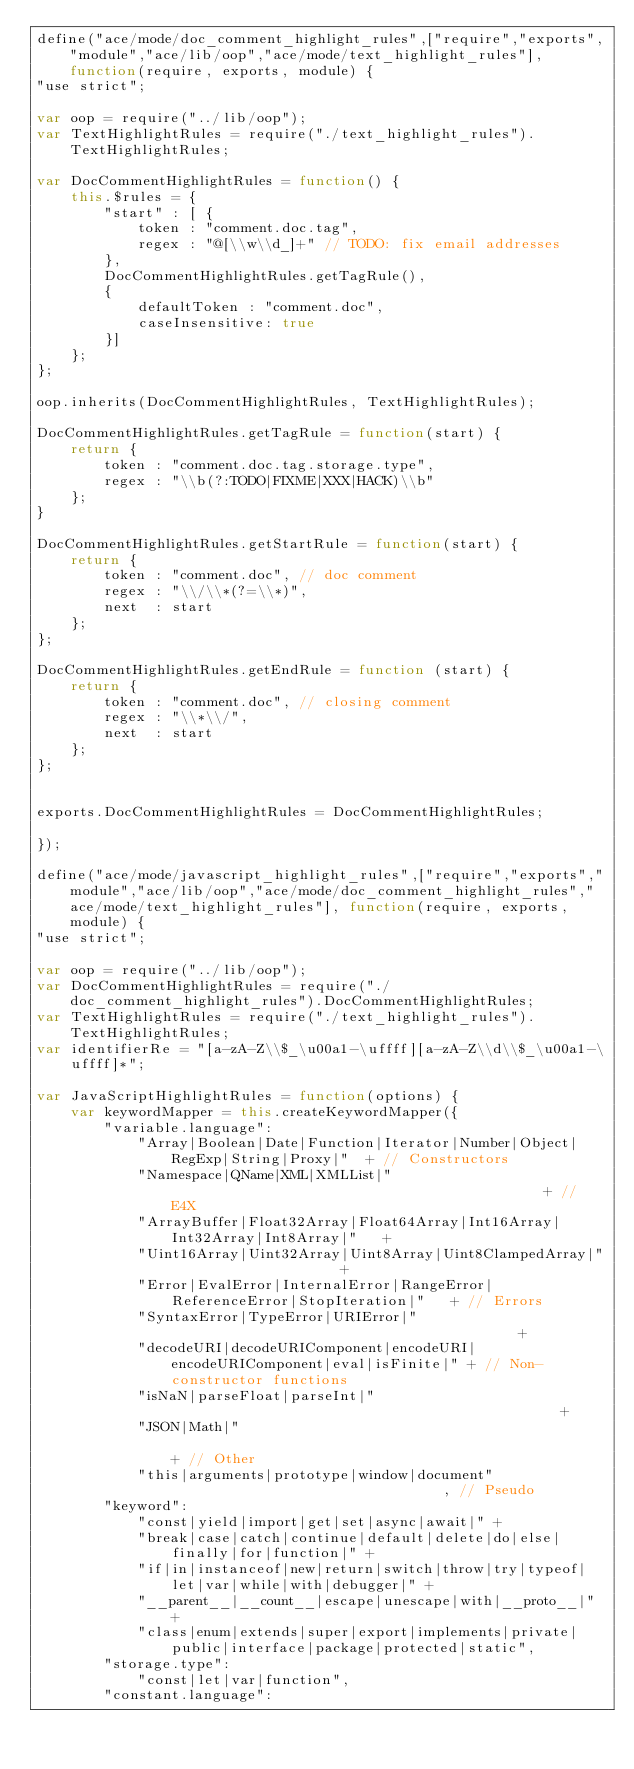<code> <loc_0><loc_0><loc_500><loc_500><_JavaScript_>define("ace/mode/doc_comment_highlight_rules",["require","exports","module","ace/lib/oop","ace/mode/text_highlight_rules"], function(require, exports, module) {
"use strict";

var oop = require("../lib/oop");
var TextHighlightRules = require("./text_highlight_rules").TextHighlightRules;

var DocCommentHighlightRules = function() {
    this.$rules = {
        "start" : [ {
            token : "comment.doc.tag",
            regex : "@[\\w\\d_]+" // TODO: fix email addresses
        }, 
        DocCommentHighlightRules.getTagRule(),
        {
            defaultToken : "comment.doc",
            caseInsensitive: true
        }]
    };
};

oop.inherits(DocCommentHighlightRules, TextHighlightRules);

DocCommentHighlightRules.getTagRule = function(start) {
    return {
        token : "comment.doc.tag.storage.type",
        regex : "\\b(?:TODO|FIXME|XXX|HACK)\\b"
    };
}

DocCommentHighlightRules.getStartRule = function(start) {
    return {
        token : "comment.doc", // doc comment
        regex : "\\/\\*(?=\\*)",
        next  : start
    };
};

DocCommentHighlightRules.getEndRule = function (start) {
    return {
        token : "comment.doc", // closing comment
        regex : "\\*\\/",
        next  : start
    };
};


exports.DocCommentHighlightRules = DocCommentHighlightRules;

});

define("ace/mode/javascript_highlight_rules",["require","exports","module","ace/lib/oop","ace/mode/doc_comment_highlight_rules","ace/mode/text_highlight_rules"], function(require, exports, module) {
"use strict";

var oop = require("../lib/oop");
var DocCommentHighlightRules = require("./doc_comment_highlight_rules").DocCommentHighlightRules;
var TextHighlightRules = require("./text_highlight_rules").TextHighlightRules;
var identifierRe = "[a-zA-Z\\$_\u00a1-\uffff][a-zA-Z\\d\\$_\u00a1-\uffff]*";

var JavaScriptHighlightRules = function(options) {
    var keywordMapper = this.createKeywordMapper({
        "variable.language":
            "Array|Boolean|Date|Function|Iterator|Number|Object|RegExp|String|Proxy|"  + // Constructors
            "Namespace|QName|XML|XMLList|"                                             + // E4X
            "ArrayBuffer|Float32Array|Float64Array|Int16Array|Int32Array|Int8Array|"   +
            "Uint16Array|Uint32Array|Uint8Array|Uint8ClampedArray|"                    +
            "Error|EvalError|InternalError|RangeError|ReferenceError|StopIteration|"   + // Errors
            "SyntaxError|TypeError|URIError|"                                          +
            "decodeURI|decodeURIComponent|encodeURI|encodeURIComponent|eval|isFinite|" + // Non-constructor functions
            "isNaN|parseFloat|parseInt|"                                               +
            "JSON|Math|"                                                               + // Other
            "this|arguments|prototype|window|document"                                 , // Pseudo
        "keyword":
            "const|yield|import|get|set|async|await|" +
            "break|case|catch|continue|default|delete|do|else|finally|for|function|" +
            "if|in|instanceof|new|return|switch|throw|try|typeof|let|var|while|with|debugger|" +
            "__parent__|__count__|escape|unescape|with|__proto__|" +
            "class|enum|extends|super|export|implements|private|public|interface|package|protected|static",
        "storage.type":
            "const|let|var|function",
        "constant.language":</code> 